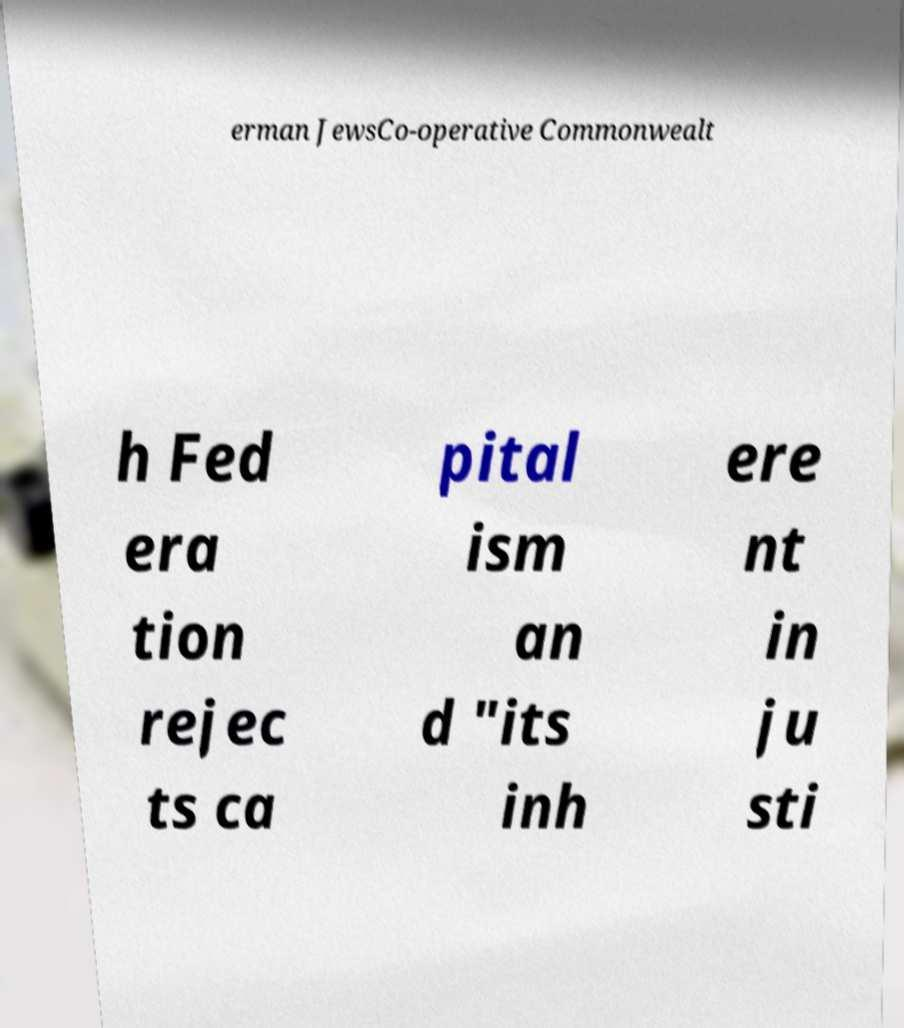Could you assist in decoding the text presented in this image and type it out clearly? erman JewsCo-operative Commonwealt h Fed era tion rejec ts ca pital ism an d "its inh ere nt in ju sti 